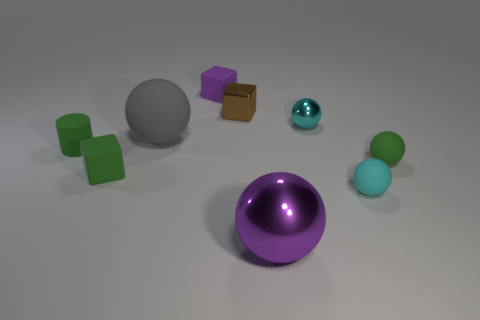Do the matte object that is right of the small cyan matte object and the large rubber thing have the same color?
Your answer should be very brief. No. How many other things are the same color as the shiny cube?
Provide a short and direct response. 0. What number of small objects are either matte spheres or shiny cubes?
Your answer should be compact. 3. Is the number of small green cylinders greater than the number of green matte objects?
Your answer should be very brief. No. Does the large gray object have the same material as the cylinder?
Your answer should be compact. Yes. Is there anything else that has the same material as the cylinder?
Provide a short and direct response. Yes. Is the number of gray balls that are behind the big gray matte thing greater than the number of cyan objects?
Keep it short and to the point. No. Does the tiny cylinder have the same color as the big rubber sphere?
Give a very brief answer. No. How many large purple things have the same shape as the tiny brown metal object?
Offer a terse response. 0. What size is the purple object that is made of the same material as the large gray object?
Offer a terse response. Small. 